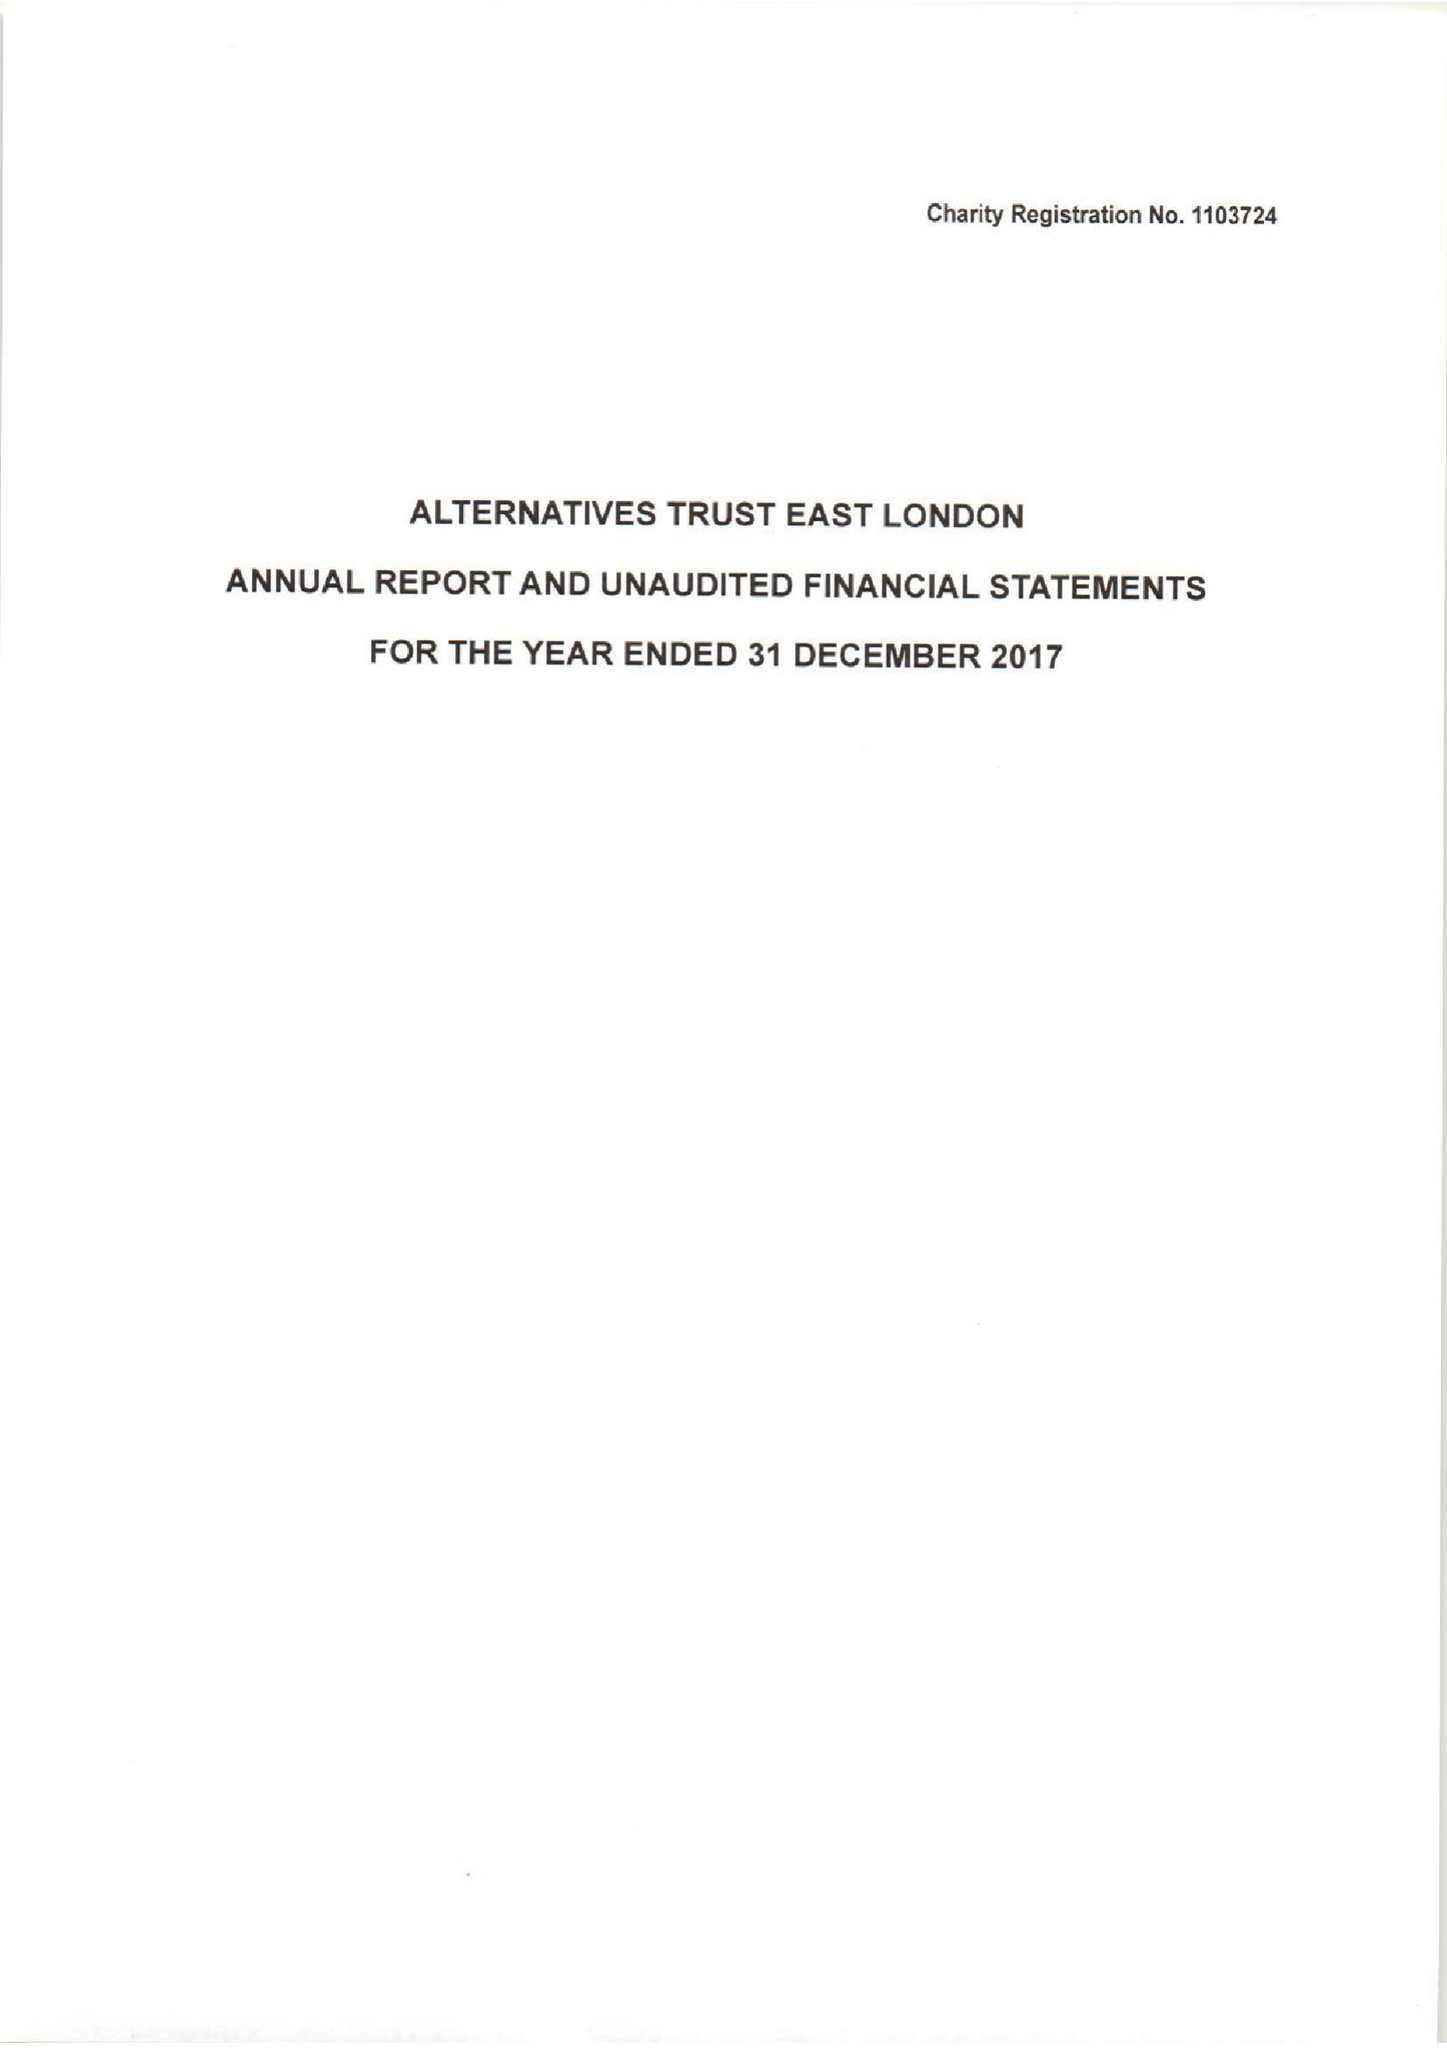What is the value for the report_date?
Answer the question using a single word or phrase. 2017-12-31 